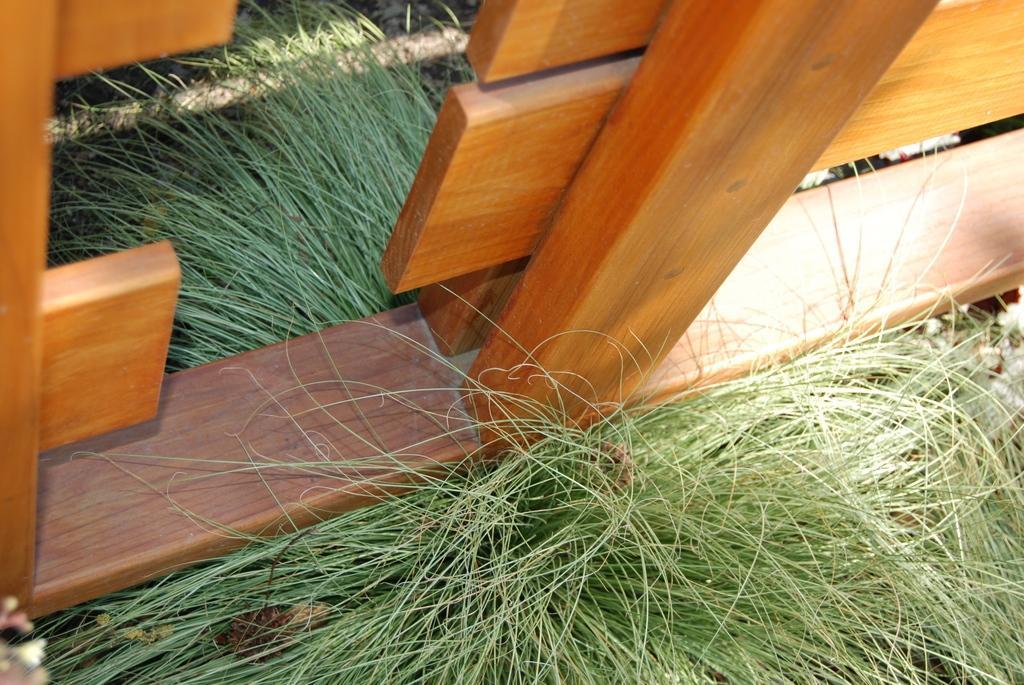Please provide a concise description of this image. In this image, we can see a wooden fence and there is green grass. 